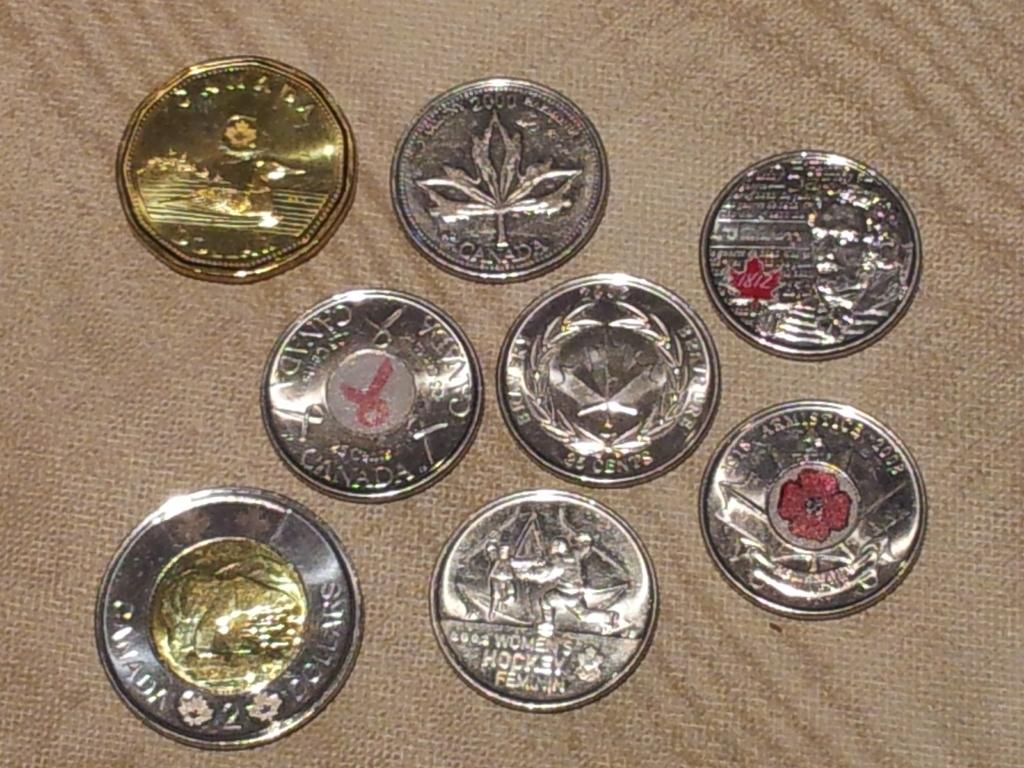Provide a one-sentence caption for the provided image. Various shiny Canadian coins are arranged on a light brown cloth. 